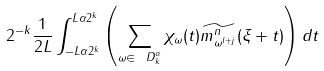Convert formula to latex. <formula><loc_0><loc_0><loc_500><loc_500>2 ^ { - k } \frac { 1 } { 2 L } \int _ { - L \alpha 2 ^ { k } } ^ { L \alpha 2 ^ { k } } \left ( \sum _ { \omega \in \ D ^ { \alpha } _ { k } } \chi _ { \omega } ( t ) \widetilde { m ^ { n } _ { \omega ^ { l + j } } } ( \xi + t ) \right ) d t</formula> 